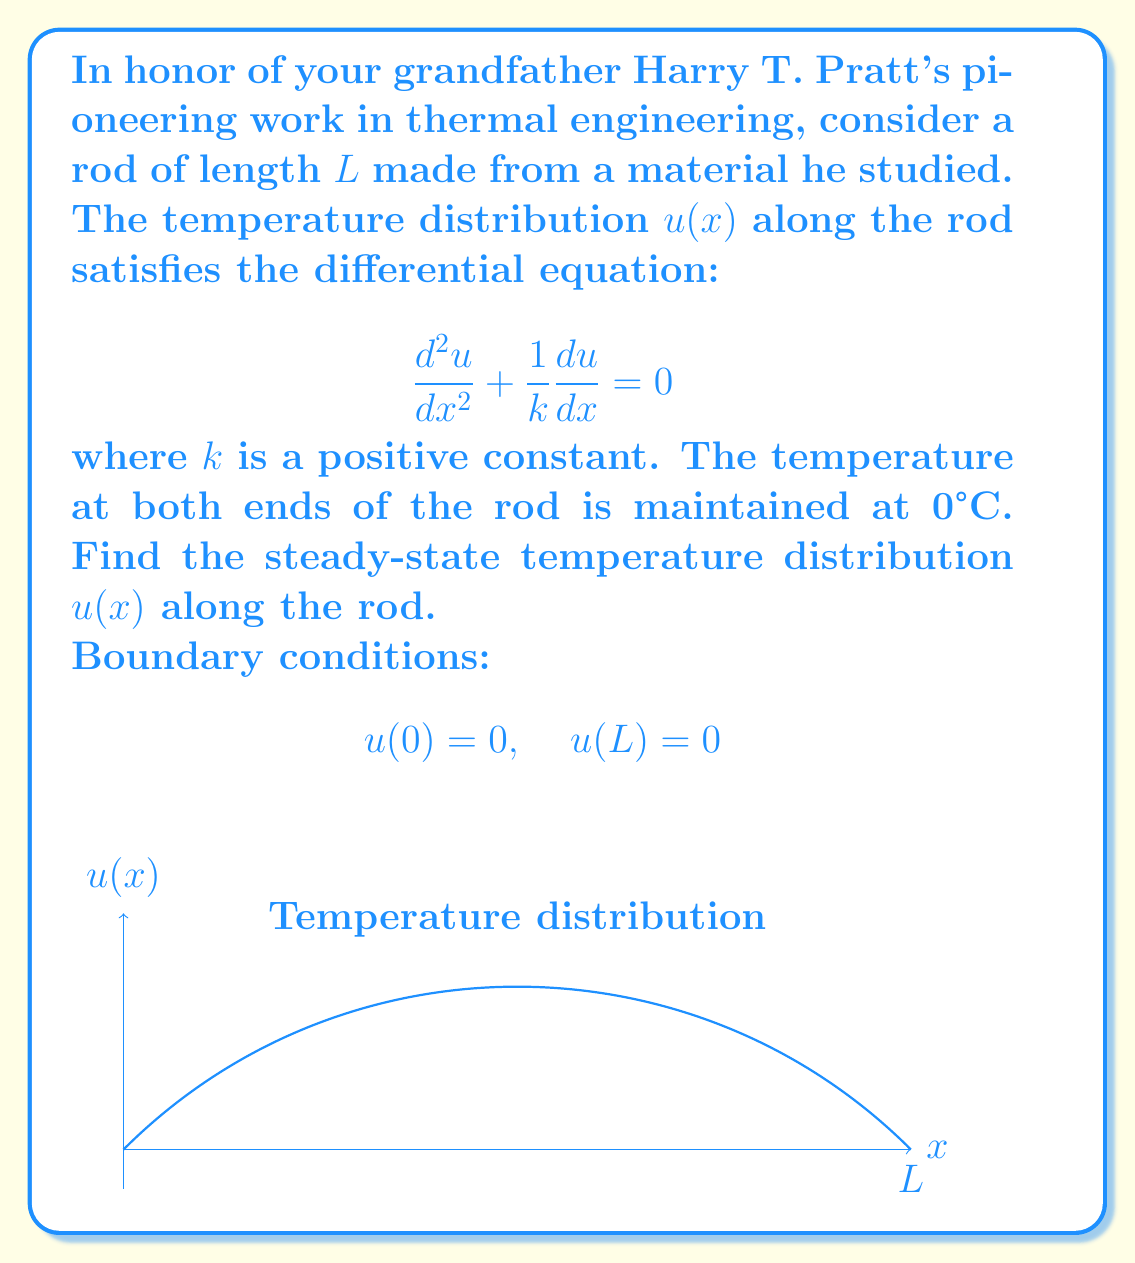Can you solve this math problem? Let's solve this step-by-step:

1) The general solution to this second-order linear equation is of the form:
   $$u(x) = A e^{-x/k} + B$$
   where A and B are constants to be determined.

2) Apply the first boundary condition, u(0) = 0:
   $$0 = A e^{0} + B \implies B = -A$$

3) Substitute this back into the general solution:
   $$u(x) = A(e^{-x/k} - 1)$$

4) Now apply the second boundary condition, u(L) = 0:
   $$0 = A(e^{-L/k} - 1)$$

5) For this to be true (and for a non-trivial solution), we must have:
   $$e^{-L/k} - 1 = 0$$
   $$e^{-L/k} = 1$$

6) However, this equation has no real solution for finite positive L and k. This means that the only solution satisfying both boundary conditions is the trivial solution:
   $$u(x) = 0 \text{ for all } x$$

This result implies that in the steady-state, with both ends of the rod maintained at 0°C, the entire rod will eventually reach a uniform temperature of 0°C.
Answer: $u(x) = 0$ for all $x \in [0,L]$ 